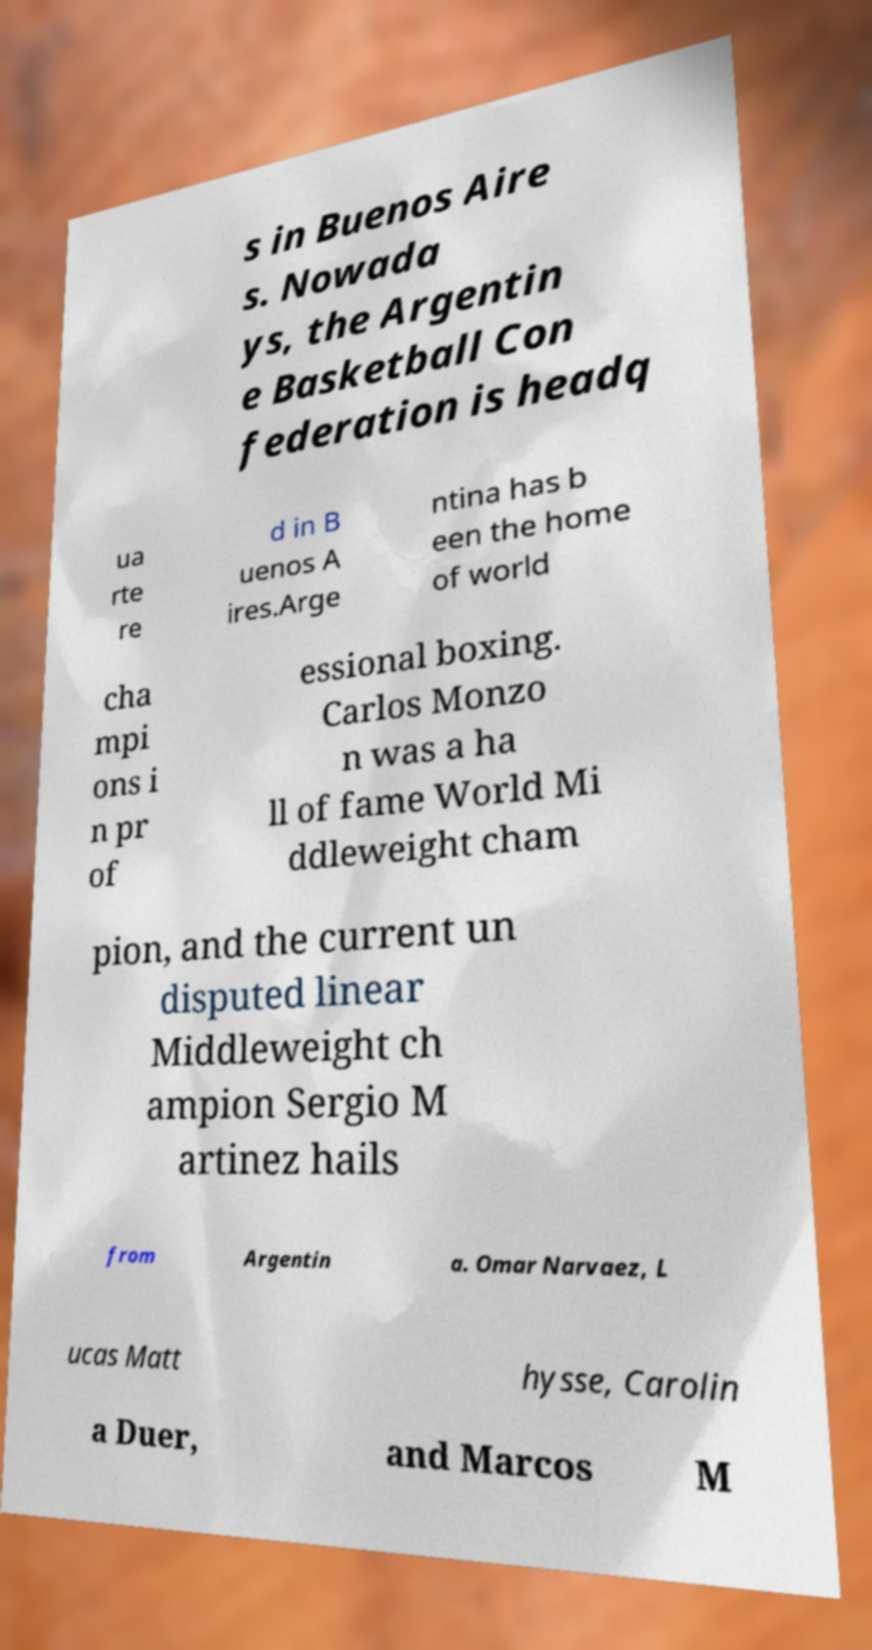Can you accurately transcribe the text from the provided image for me? s in Buenos Aire s. Nowada ys, the Argentin e Basketball Con federation is headq ua rte re d in B uenos A ires.Arge ntina has b een the home of world cha mpi ons i n pr of essional boxing. Carlos Monzo n was a ha ll of fame World Mi ddleweight cham pion, and the current un disputed linear Middleweight ch ampion Sergio M artinez hails from Argentin a. Omar Narvaez, L ucas Matt hysse, Carolin a Duer, and Marcos M 